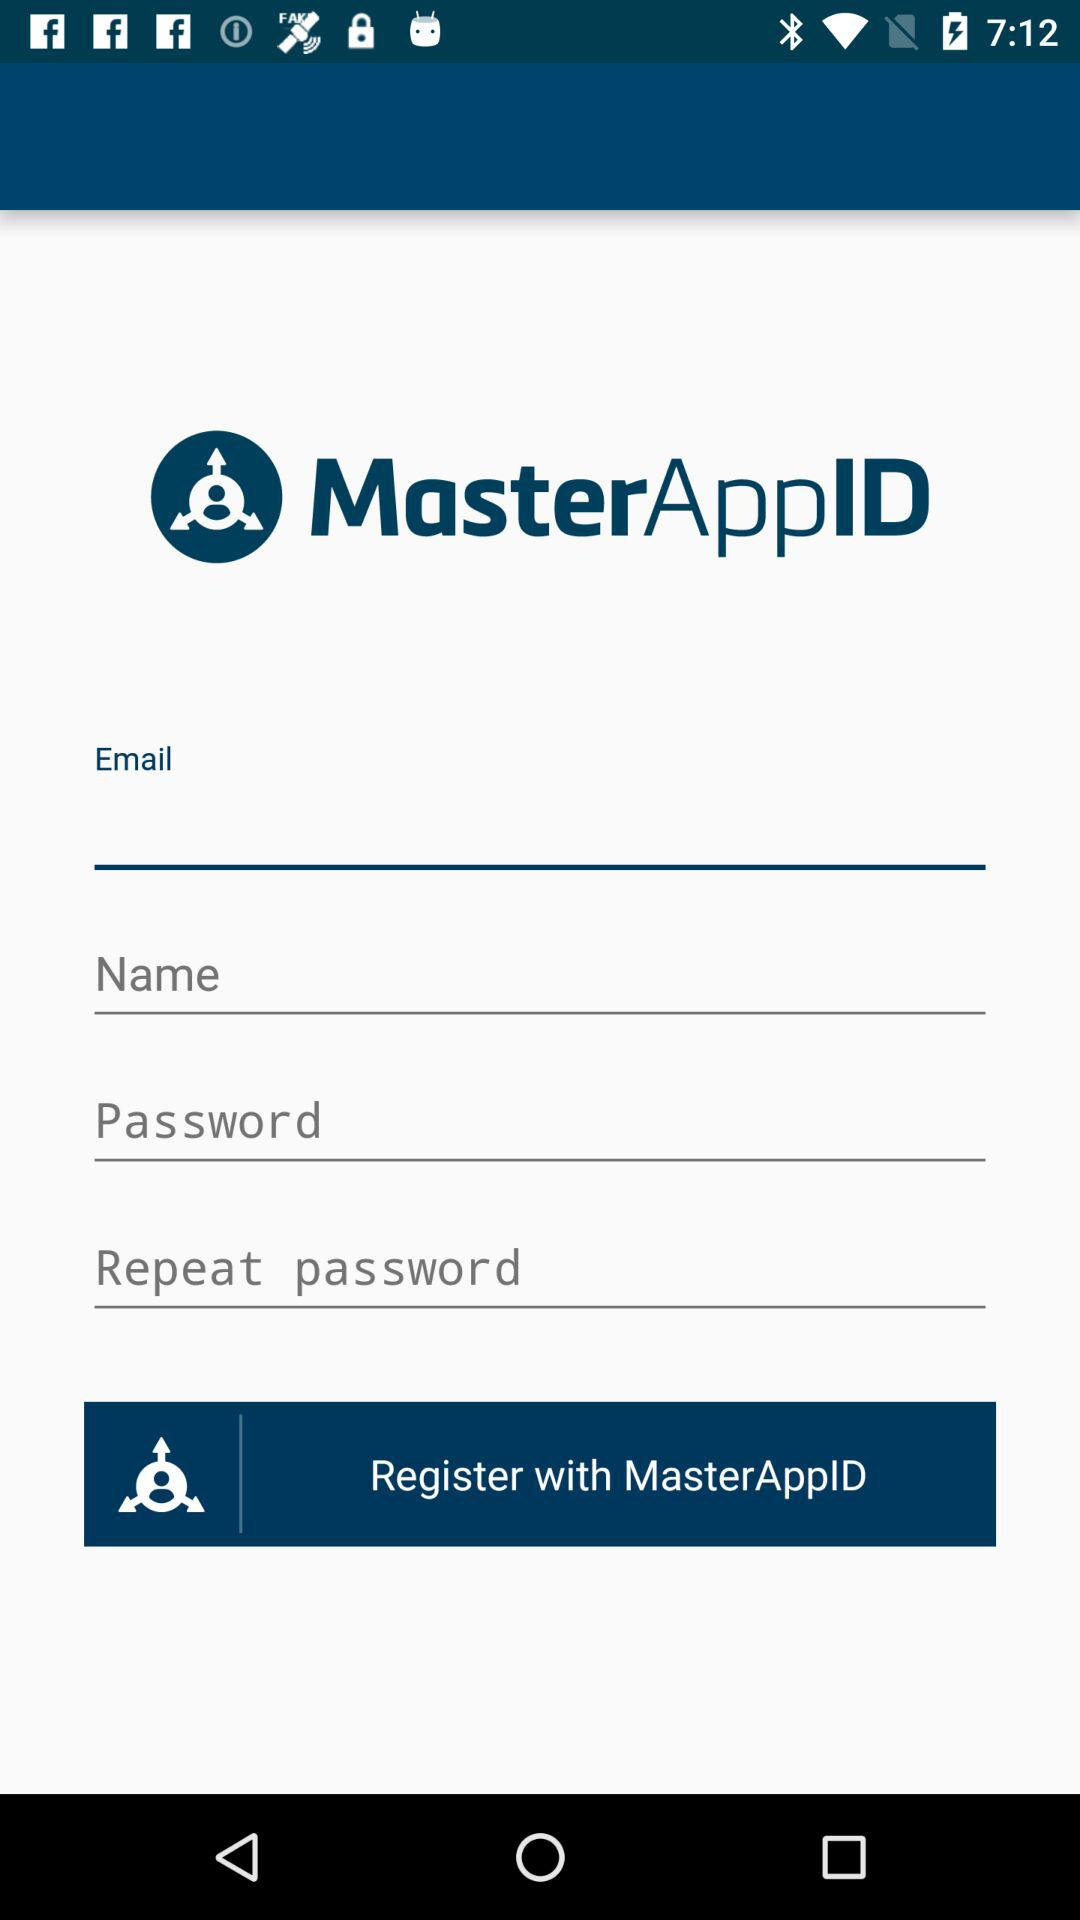What is the application name? The application name is "MasterAppID". 